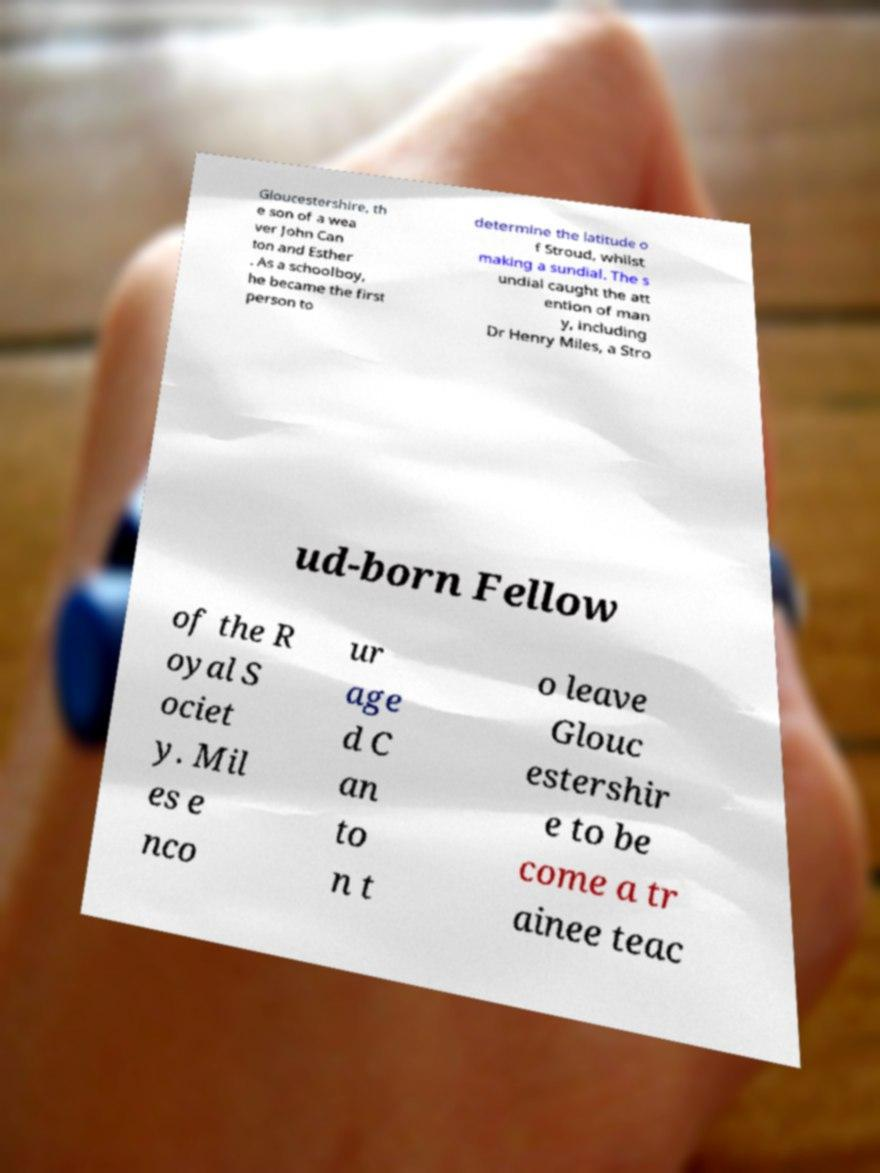Please identify and transcribe the text found in this image. Gloucestershire, th e son of a wea ver John Can ton and Esther . As a schoolboy, he became the first person to determine the latitude o f Stroud, whilst making a sundial. The s undial caught the att ention of man y, including Dr Henry Miles, a Stro ud-born Fellow of the R oyal S ociet y. Mil es e nco ur age d C an to n t o leave Glouc estershir e to be come a tr ainee teac 